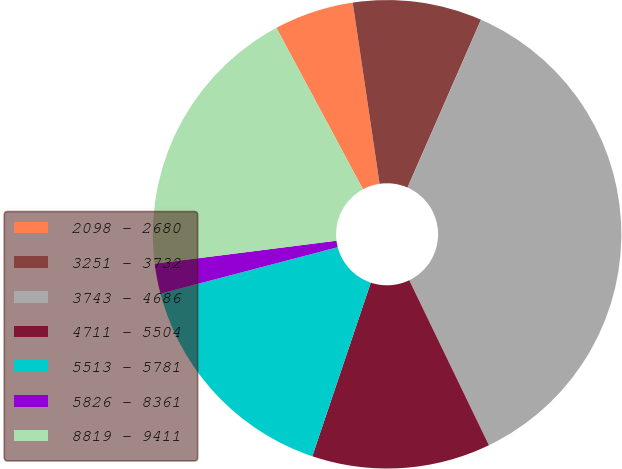<chart> <loc_0><loc_0><loc_500><loc_500><pie_chart><fcel>2098 - 2680<fcel>3251 - 3732<fcel>3743 - 4686<fcel>4711 - 5504<fcel>5513 - 5781<fcel>5826 - 8361<fcel>8819 - 9411<nl><fcel>5.49%<fcel>8.91%<fcel>36.27%<fcel>12.33%<fcel>15.75%<fcel>2.07%<fcel>19.17%<nl></chart> 